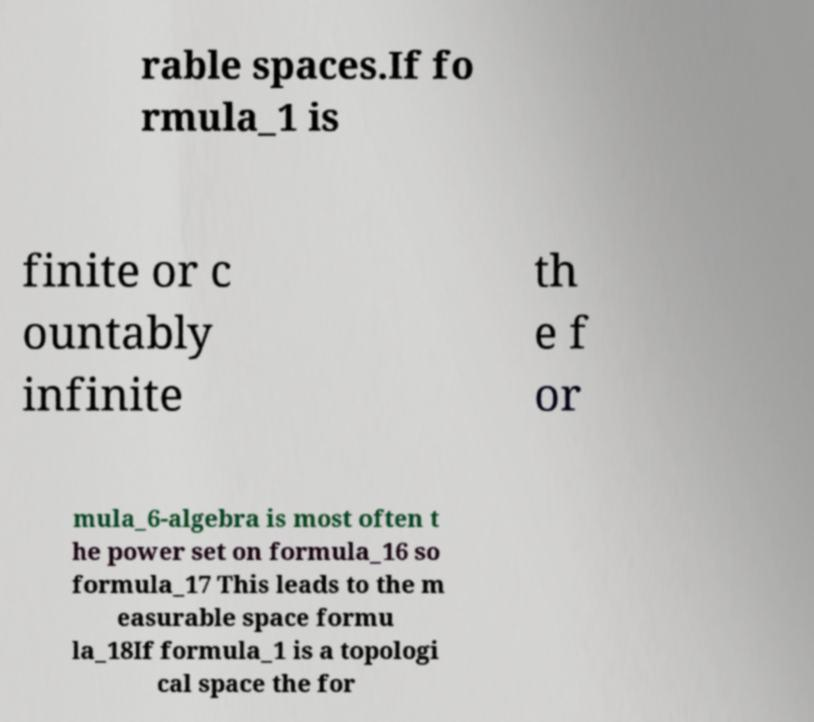Please identify and transcribe the text found in this image. rable spaces.If fo rmula_1 is finite or c ountably infinite th e f or mula_6-algebra is most often t he power set on formula_16 so formula_17 This leads to the m easurable space formu la_18If formula_1 is a topologi cal space the for 